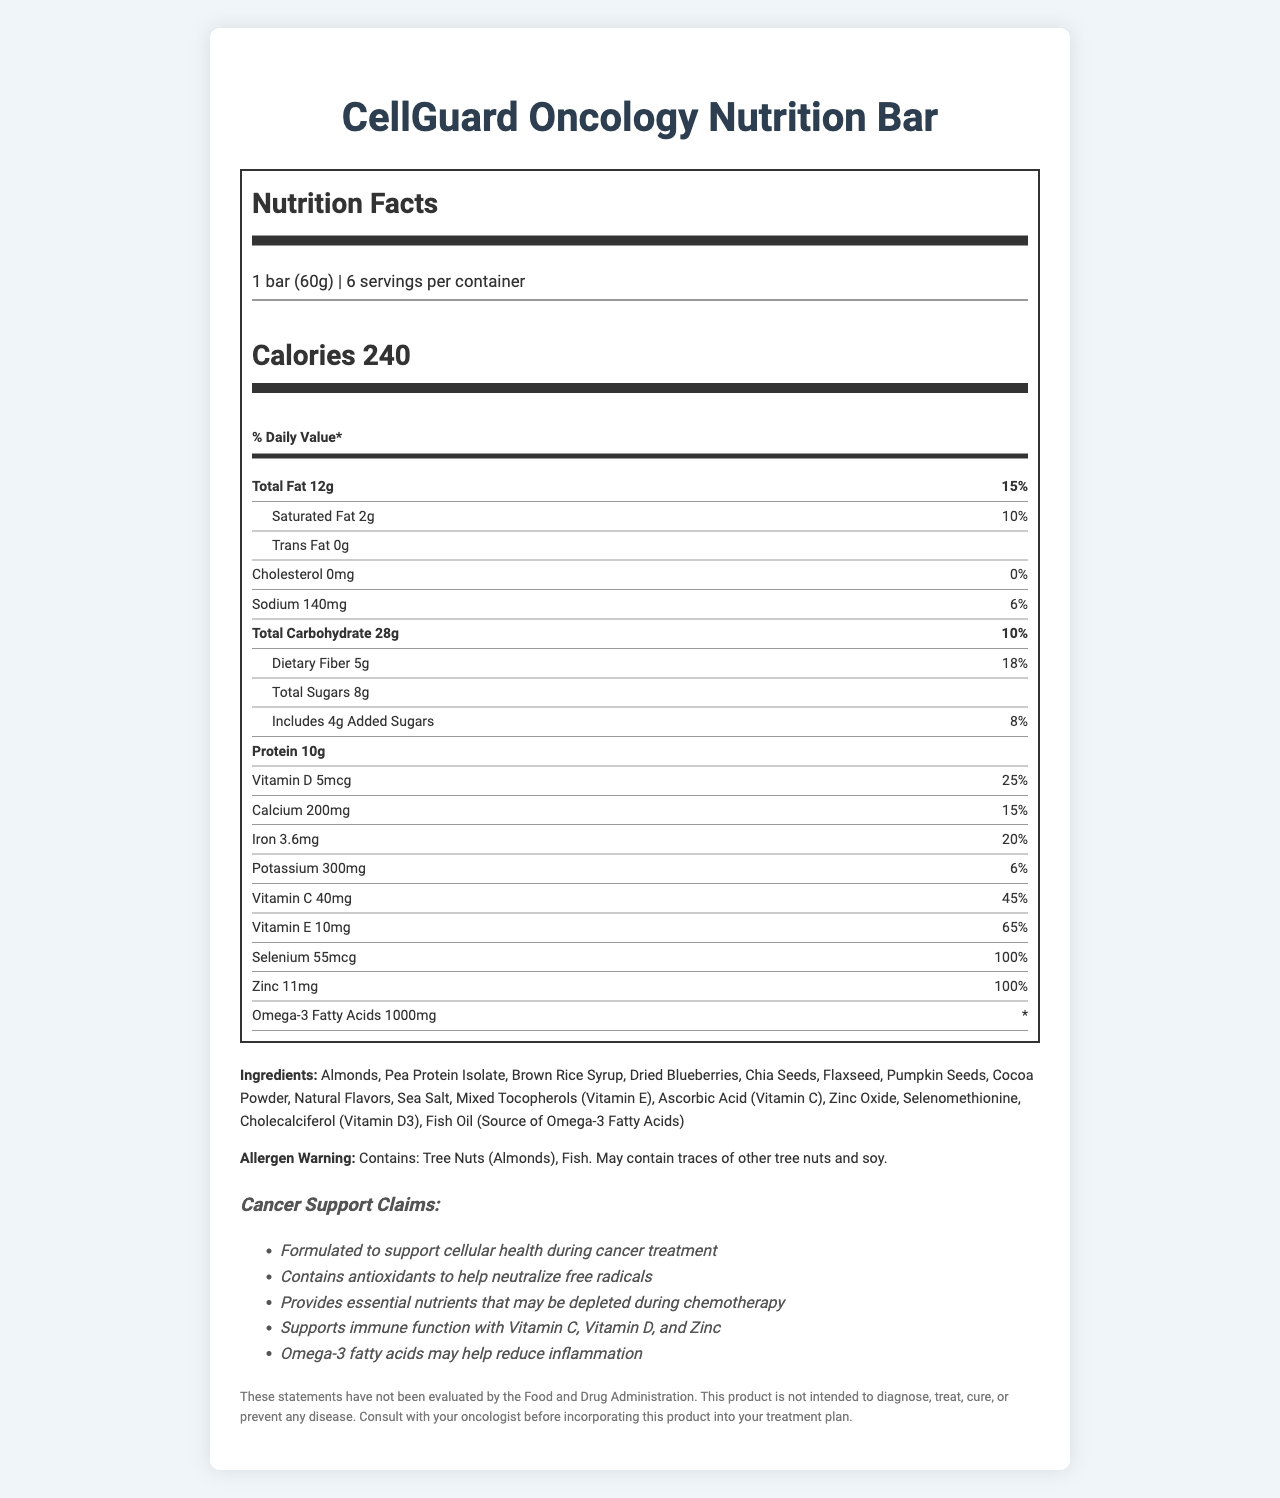what is the serving size of the CellGuard Oncology Nutrition Bar? The serving size is mentioned directly under the product name and labeled as "1 bar (60g)".
Answer: 1 bar (60g) how many servings per container are there? The servings per container are listed below the serving size.
Answer: 6 how many calories are there per serving? The calorie count per serving is prominently displayed just below the serving information.
Answer: 240 what percentage of the daily value is the total fat content? The percentage of daily value for total fat is noted right next to the total fat amount.
Answer: 15% what are the ingredients in the CellGuard Oncology Nutrition Bar? The list of ingredients is provided in the ingredients section towards the end of the document.
Answer: Almonds, Pea Protein Isolate, Brown Rice Syrup, Dried Blueberries, Chia Seeds, Flaxseed, Pumpkin Seeds, Cocoa Powder, Natural Flavors, Sea Salt, Mixed Tocopherols (Vitamin E), Ascorbic Acid (Vitamin C), Zinc Oxide, Selenomethionine, Cholecalciferol (Vitamin D3), Fish Oil (Source of Omega-3 Fatty Acids) how much protein is in each serving of the bar? The amount of protein per serving is listed in the nutrition label in the bold section.
Answer: 10g how much Vitamin C is in each serving? The amount of Vitamin C per serving is listed towards the end of the nutrition label.
Answer: 40mg which of the following nutrients has the highest percentage daily value in the bar? A. Vitamin C B. Zinc C. Calcium D. Vitamin D Zinc has a 100% daily value, while other nutrients like Vitamin C, Calcium, and Vitamin D have less.
Answer: B. Zinc how many milligrams of sodium are in each serving? The sodium content is listed in the main body of the nutrition label.
Answer: 140mg True or false: The CellGuard Oncology Nutrition Bar contains no added sugars. The bar contains 4g of added sugars, as indicated in the nutrition label under total sugars.
Answer: False does this product contain fish oil? Fish oil is listed as one of the ingredients.
Answer: Yes summarize the main purpose of the CellGuard Oncology Nutrition Bar. The purpose of the bar, as indicated by the cancer support claims and ingredients, is to support cellular health and provide essential nutrients during cancer treatment.
Answer: The CellGuard Oncology Nutrition Bar is formulated to support cellular health during cancer treatment by providing essential nutrients, antioxidants, and omega-3 fatty acids. It contains specific vitamins and minerals to support immune function and reduce inflammation. what is the total carbohydrate content per serving in grams? The total carbohydrate content is shown in the bold section of the nutrition label.
Answer: 28g which of the following is an antioxidant mentioned in the document? A. Vitamin E B. Sodium C. Saturated Fat D. Trans Fat The claims section mentions that the product contains antioxidants, and Vitamin E (with a 65% daily value) is specifically identified.
Answer: A. Vitamin E what type of tree nuts does the product contain? The allergen warning section states that the product contains tree nuts (Almonds).
Answer: Almonds how does the bar support immune function according to the document? The claims section mentions that these specific vitamins and minerals support immune function.
Answer: With Vitamin C, Vitamin D, and Zinc what are the special instructions about the product's ability to diagnose, treat, cure, or prevent diseases? The disclaimer section provides this information.
Answer: These statements have not been evaluated by the Food and Drug Administration. This product is not intended to diagnose, treat, cure, or prevent any disease. what is the form of selenium added to the bar? Selenomethionine is listed as one of the ingredients.
Answer: Selenomethionine how many grams of dietary fiber are in each serving of the bar? The dietary fiber content is noted under the total carbohydrate section in the nutrition label.
Answer: 5g does the product contain any soy? The allergen warning section notes that it may contain traces of soy, but does not confirm its presence.
Answer: May contain traces of soy who should you consult before incorporating this product into your treatment plan? The disclaimer advises consulting with your oncologist before using the product.
Answer: Your oncologist 